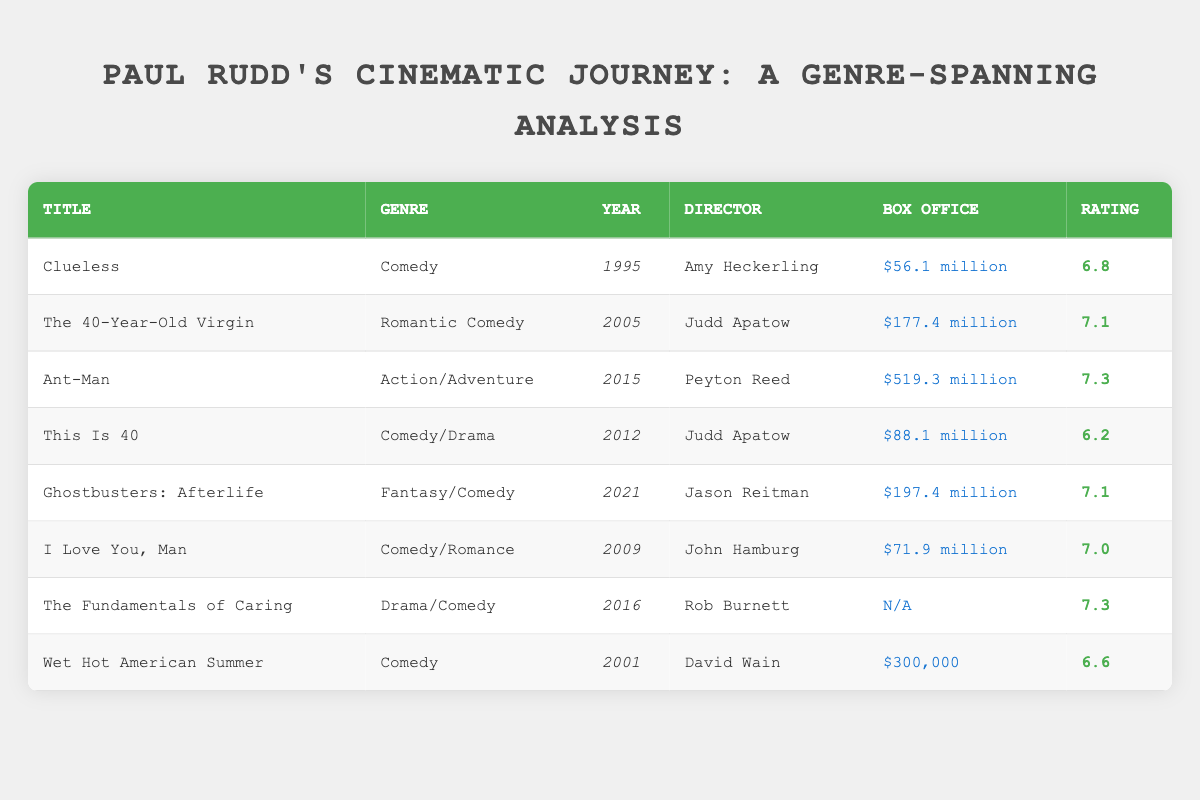What is the highest box office revenue among Paul Rudd's films listed? The box office revenues from the films listed are $56.1 million for "Clueless," $177.4 million for "The 40-Year-Old Virgin," $519.3 million for "Ant-Man," $88.1 million for "This Is 40," $197.4 million for "Ghostbusters: Afterlife," $71.9 million for "I Love You, Man," $N/A for "The Fundamentals of Caring," and $300,000 for "Wet Hot American Summer." The highest value is $519.3 million from "Ant-Man."
Answer: $519.3 million Which genre has the highest average rating? The ratings for each genre are: Comedy (6.8, 6.6, 6.2), Romantic Comedy (7.1), Action/Adventure (7.3), Comedy/Drama (7.3), Fantasy/Comedy (7.1), and Drama/Comedy (7.3). For Comedy, the average is (6.8 + 6.6 + 6.2) / 3 = 6.53. For Romantic Comedy, it is 7.1. For Action/Adventure, it is 7.3. For Comedy/Drama and Fantasy/Comedy, both also average to 7.3. The highest average rating is therefore 7.3, which occurs in the Action/Adventure, Comedy/Drama, and Drama/Comedy genres.
Answer: Action/Adventure, Comedy/Drama, Drama/Comedy Was "Wet Hot American Summer" more commercially successful than "Clueless"? "Wet Hot American Summer" had box office earnings of $300,000 while "Clueless" earned $56.1 million, meaning "Wet Hot American Summer" was significantly less successful. To determine this, you simply compare the two values: $300,000 is less than $56.1 million.
Answer: No How many films directed by Judd Apatow are in the list, and what are their ratings? The films directed by Judd Apatow are "The 40-Year-Old Virgin" (7.1) and "This Is 40" (6.2). There are two films in total.
Answer: 2 films: 7.1, 6.2 Which film from 2021 has a higher rating: "Ghostbusters: Afterlife" or "This Is 40"? "Ghostbusters: Afterlife," released in 2021, has a rating of 7.1, while "This Is 40," released in 2012, has a rating of 6.2. Comparing the two ratings, 7.1 is indeed higher than 6.2.
Answer: Higher rating is for "Ghostbusters: Afterlife" What genre does the film with the lowest box office revenue belong to? The film with the lowest box office revenue is "Wet Hot American Summer," with earnings of $300,000. To find the genre, you refer to the relevant entry in the table, which states its genre is Comedy.
Answer: Comedy 